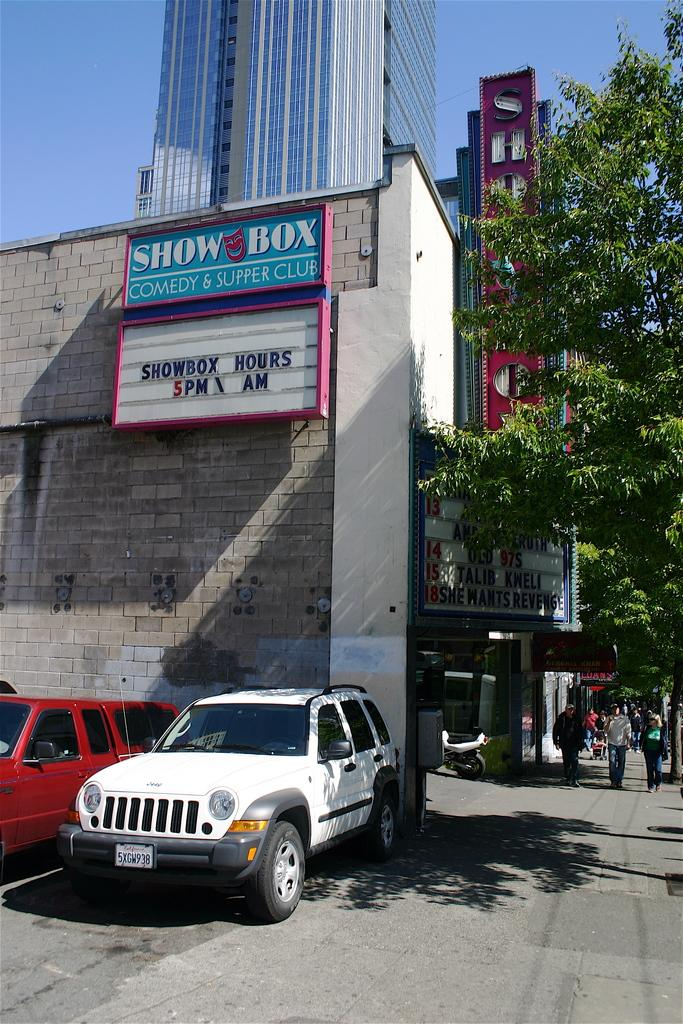<image>
Provide a brief description of the given image. The sign above the cars advertises a comedy and supper club. 